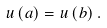Convert formula to latex. <formula><loc_0><loc_0><loc_500><loc_500>u \left ( a \right ) = u \left ( b \right ) .</formula> 